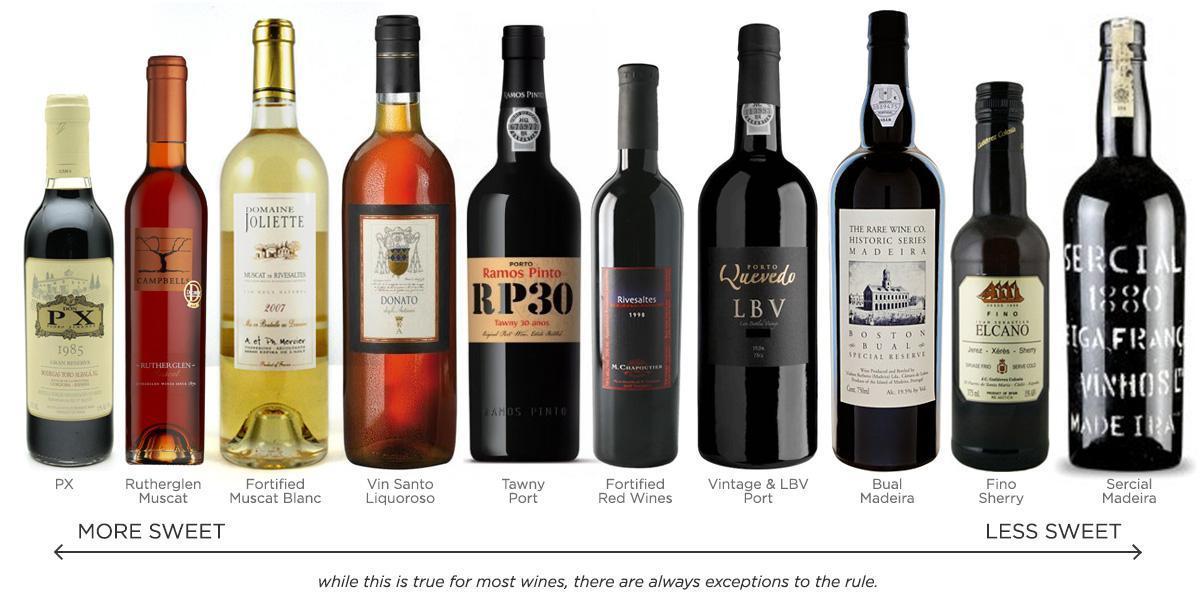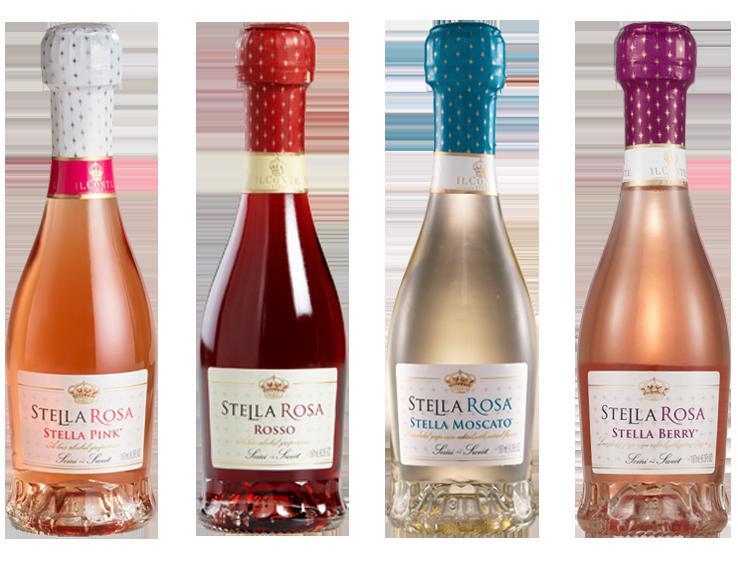The first image is the image on the left, the second image is the image on the right. For the images shown, is this caption "Seven different unopened bottles of wine are lined up in each image." true? Answer yes or no. No. 